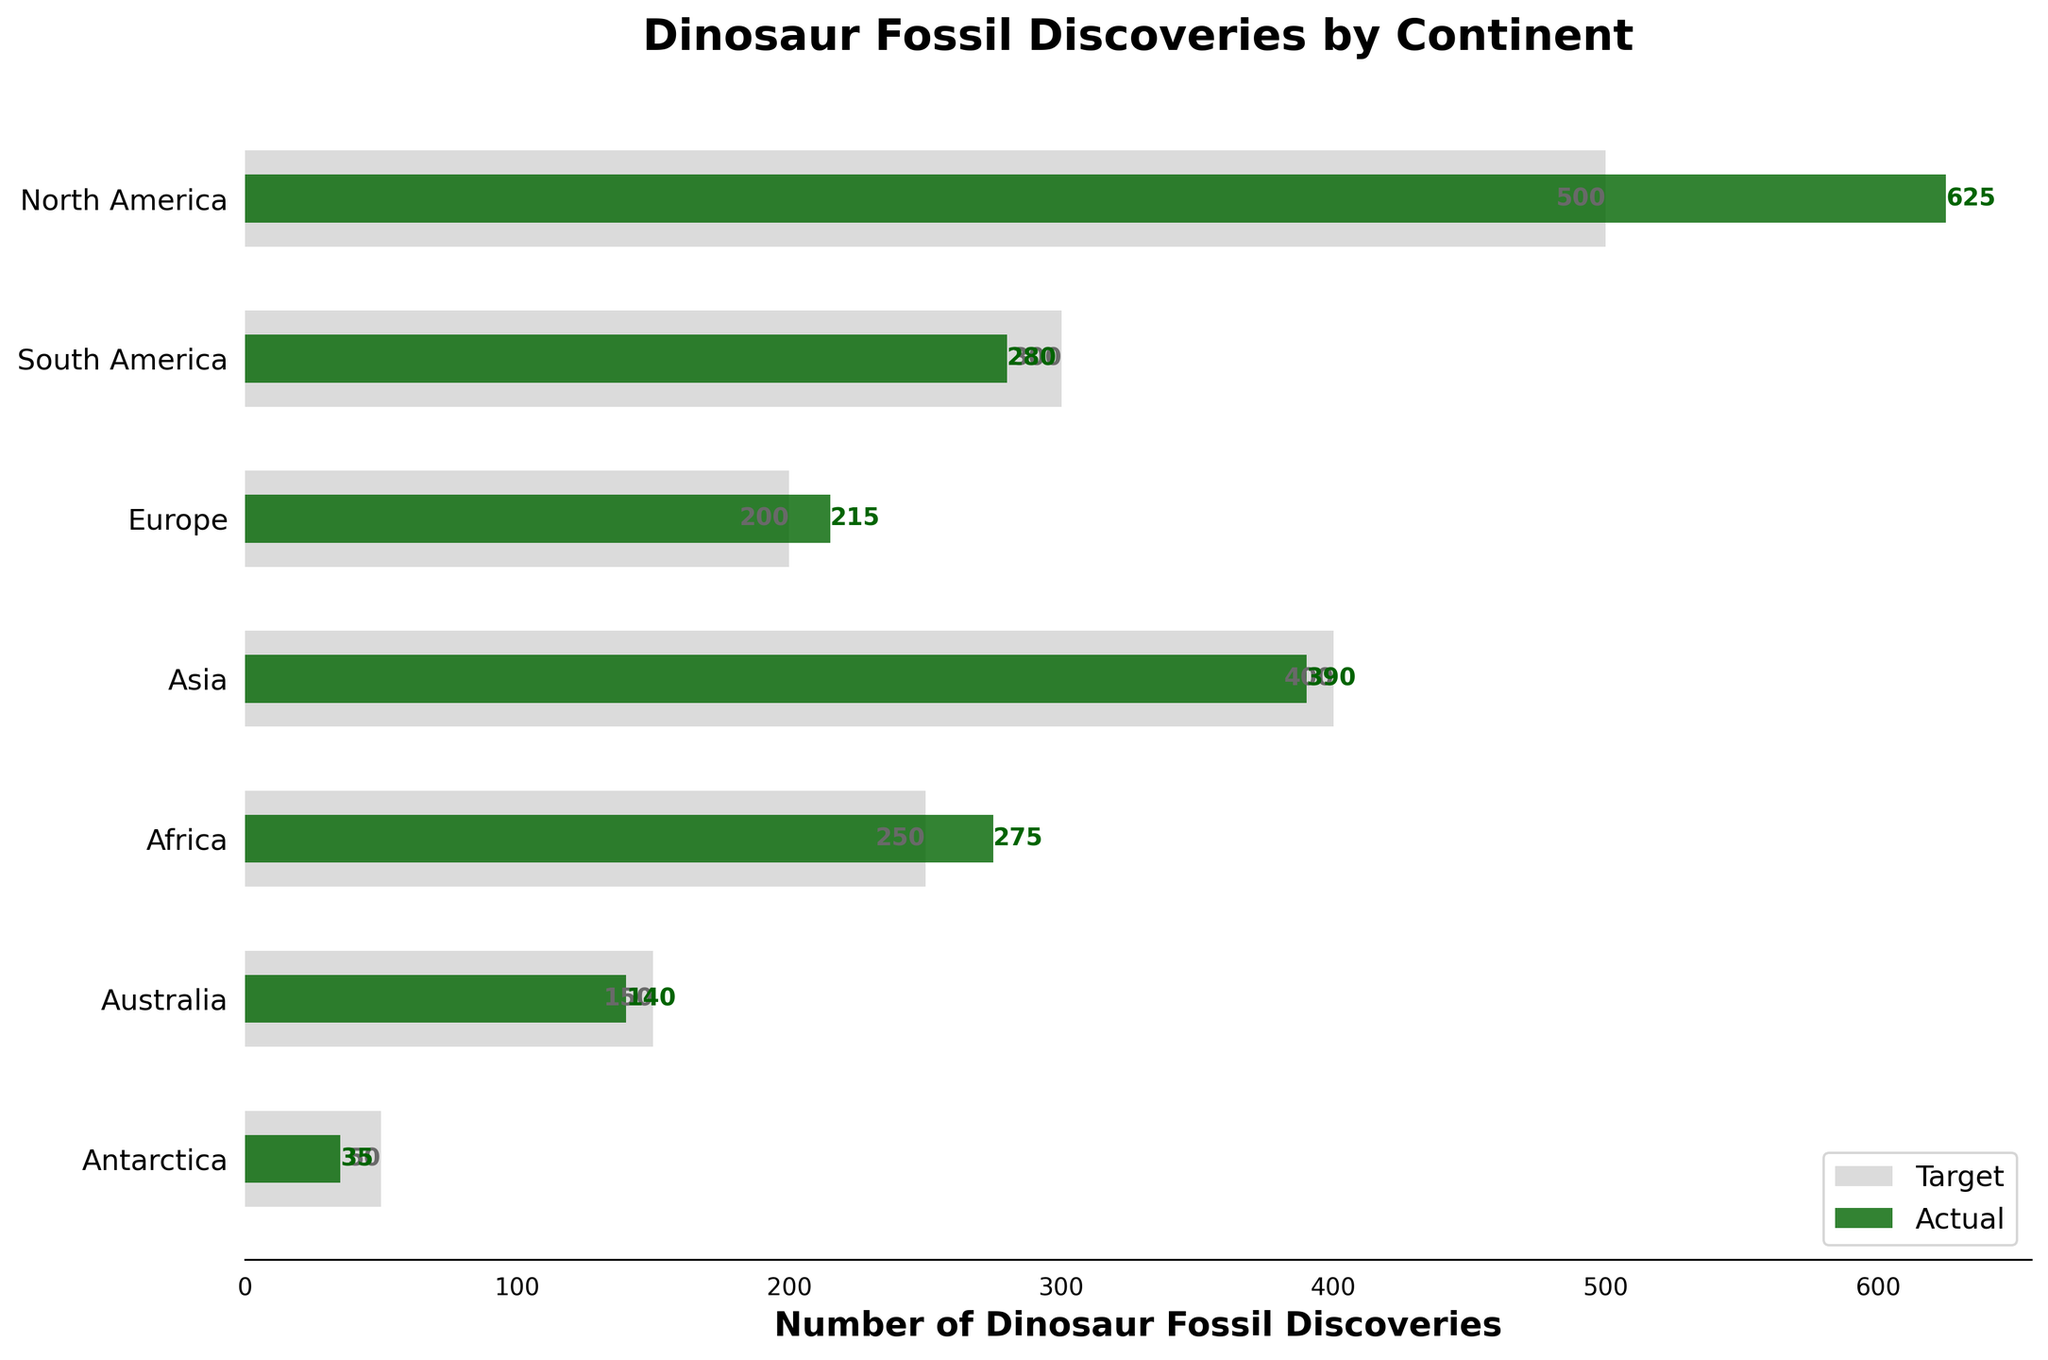What is the title of the chart? The title of the chart is located at the top and reads "Dinosaur Fossil Discoveries by Continent."
Answer: Dinosaur Fossil Discoveries by Continent Which continent has the highest number of actual dinosaur fossil discoveries? Look at the length of the dark green bars for each continent. The longest bar represents the highest number of actual discoveries, which is North America.
Answer: North America How many actual dinosaur fossil discoveries were made in Africa? Find the dark green bar corresponding to Africa and read the value on the bar or the number written next to it, which is 275.
Answer: 275 What is the target number of dinosaur fossil discoveries for Asia? Find the light grey bar corresponding to Asia and read the value on the bar or the number written next to it, which is 400.
Answer: 400 How many more actual discoveries were made in North America compared to Europe? Subtract the number of actual discoveries in Europe (215) from that in North America (625): 625 - 215 = 410.
Answer: 410 In which continent did the actual discoveries exceed the target? Compare the lengths of the dark green and light grey bars for each continent. North America, Europe, and Africa have longer dark green bars than light grey bars, indicating actual discoveries exceeded targets.
Answer: North America, Europe, Africa Which continent has the smallest number of actual discoveries? Look for the shortest dark green bar among all the continents, which is Antarctica, with 35 discoveries.
Answer: Antarctica How many continents have a target of at least 300 discoveries? Count the number of continents where the light grey bar is equal to or exceeds 300. These continents are North America, South America, and Asia.
Answer: 3 What is the difference between the target and actual discoveries in Australia? Subtract the number of actual discoveries (140) from the target (150): 150 - 140 = 10.
Answer: 10 Which continents have underachieved their target discoveries? Compare the lengths of the dark green and light grey bars for each continent. South America, Asia, Australia, and Antarctica have shorter dark green bars than light grey bars, indicating target underachievement.
Answer: South America, Asia, Australia, Antarctica 